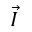<formula> <loc_0><loc_0><loc_500><loc_500>\vec { I }</formula> 